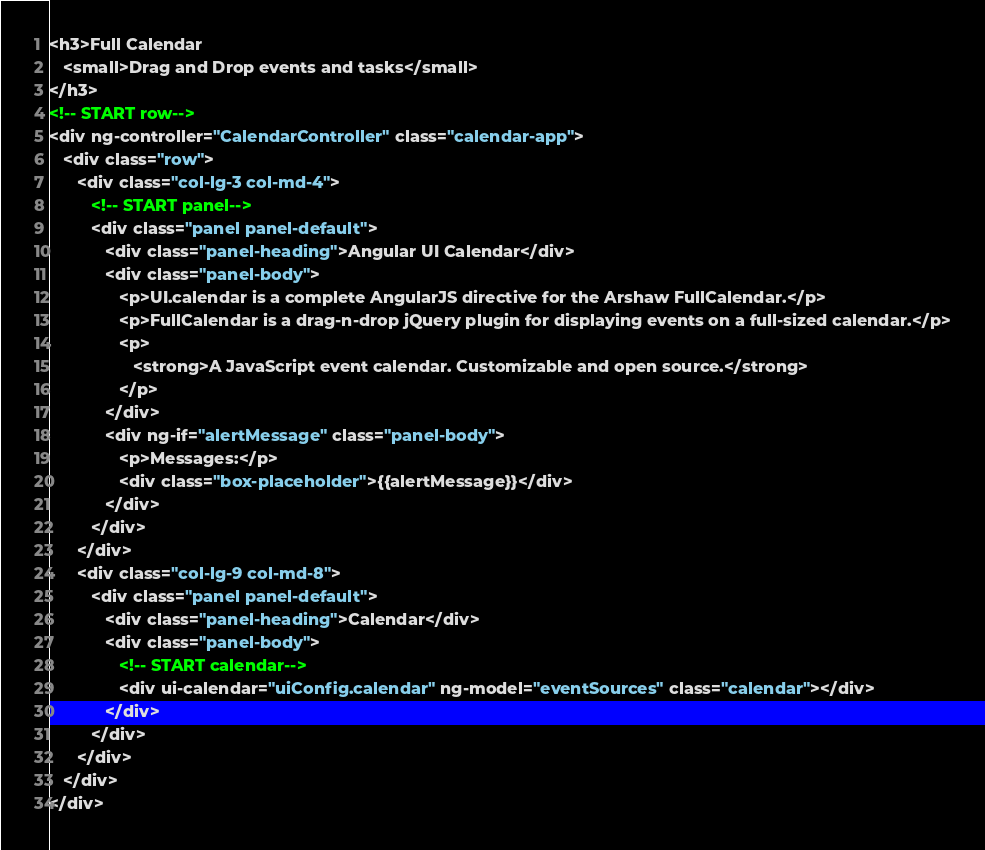<code> <loc_0><loc_0><loc_500><loc_500><_HTML_><h3>Full Calendar
   <small>Drag and Drop events and tasks</small>
</h3>
<!-- START row-->
<div ng-controller="CalendarController" class="calendar-app">
   <div class="row">
      <div class="col-lg-3 col-md-4">
         <!-- START panel-->
         <div class="panel panel-default">
            <div class="panel-heading">Angular UI Calendar</div>
            <div class="panel-body">
               <p>UI.calendar is a complete AngularJS directive for the Arshaw FullCalendar.</p>
               <p>FullCalendar is a drag-n-drop jQuery plugin for displaying events on a full-sized calendar.</p>
               <p>
                  <strong>A JavaScript event calendar. Customizable and open source.</strong>
               </p>
            </div>
            <div ng-if="alertMessage" class="panel-body">
               <p>Messages:</p>
               <div class="box-placeholder">{{alertMessage}}</div>
            </div>
         </div>
      </div>
      <div class="col-lg-9 col-md-8">
         <div class="panel panel-default">
            <div class="panel-heading">Calendar</div>
            <div class="panel-body">
               <!-- START calendar-->
               <div ui-calendar="uiConfig.calendar" ng-model="eventSources" class="calendar"></div>
            </div>
         </div>
      </div>
   </div>
</div></code> 